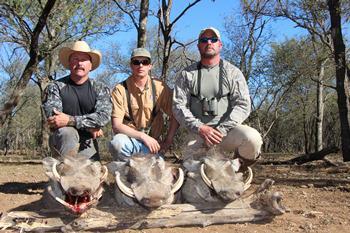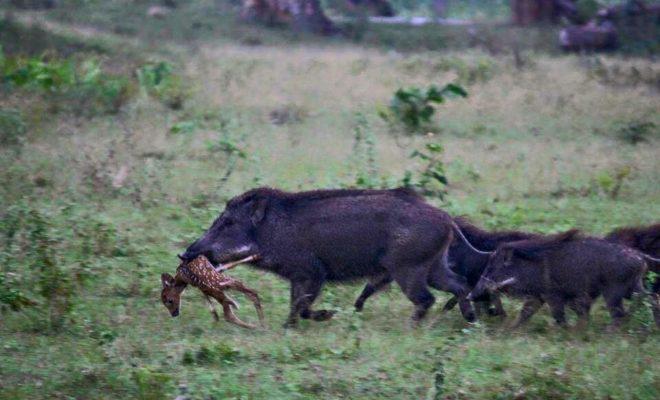The first image is the image on the left, the second image is the image on the right. Assess this claim about the two images: "there is exactly one human in the image on the left". Correct or not? Answer yes or no. No. 